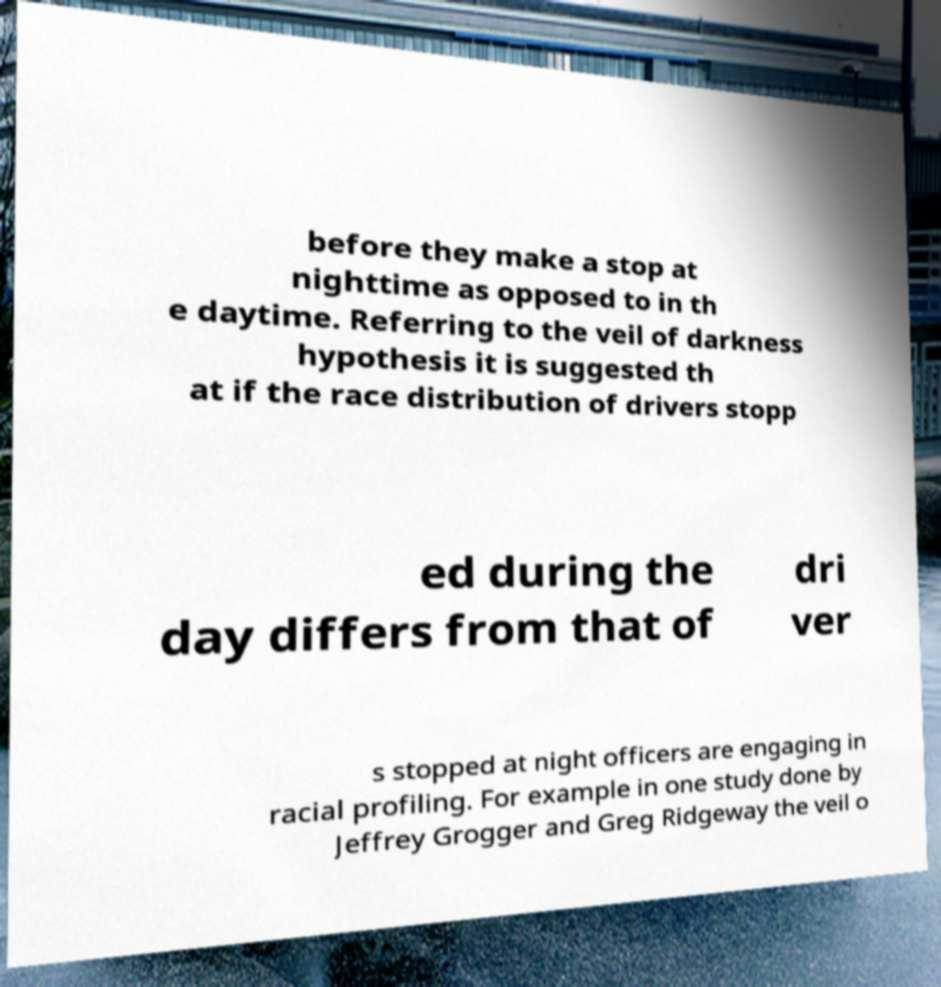Can you read and provide the text displayed in the image?This photo seems to have some interesting text. Can you extract and type it out for me? before they make a stop at nighttime as opposed to in th e daytime. Referring to the veil of darkness hypothesis it is suggested th at if the race distribution of drivers stopp ed during the day differs from that of dri ver s stopped at night officers are engaging in racial profiling. For example in one study done by Jeffrey Grogger and Greg Ridgeway the veil o 